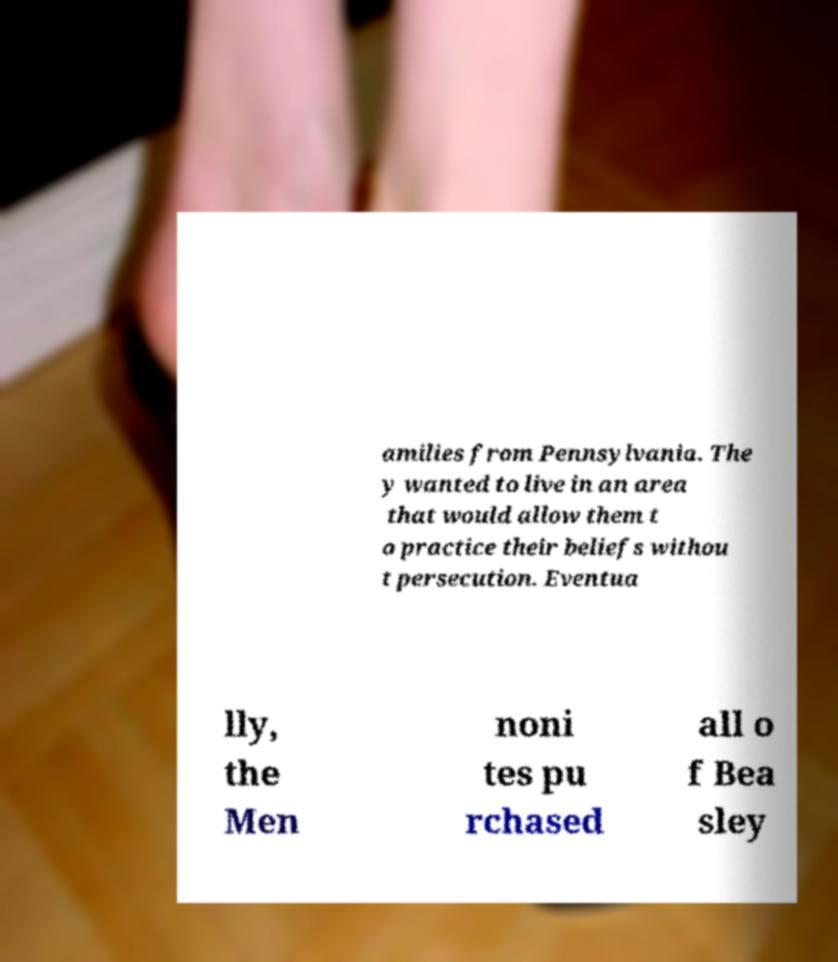What messages or text are displayed in this image? I need them in a readable, typed format. amilies from Pennsylvania. The y wanted to live in an area that would allow them t o practice their beliefs withou t persecution. Eventua lly, the Men noni tes pu rchased all o f Bea sley 